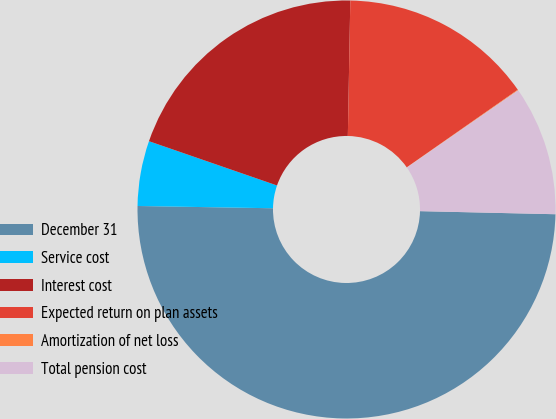Convert chart. <chart><loc_0><loc_0><loc_500><loc_500><pie_chart><fcel>December 31<fcel>Service cost<fcel>Interest cost<fcel>Expected return on plan assets<fcel>Amortization of net loss<fcel>Total pension cost<nl><fcel>49.9%<fcel>5.03%<fcel>19.99%<fcel>15.0%<fcel>0.05%<fcel>10.02%<nl></chart> 